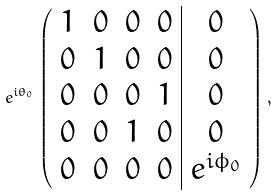Convert formula to latex. <formula><loc_0><loc_0><loc_500><loc_500>e ^ { i \theta _ { 0 } } \left ( \begin{array} { c c c c | c } 1 & 0 & 0 & 0 & 0 \\ 0 & 1 & 0 & 0 & 0 \\ 0 & 0 & 0 & 1 & 0 \\ 0 & 0 & 1 & 0 & 0 \\ 0 & 0 & 0 & 0 & e ^ { i \phi _ { 0 } } \end{array} \right ) ,</formula> 